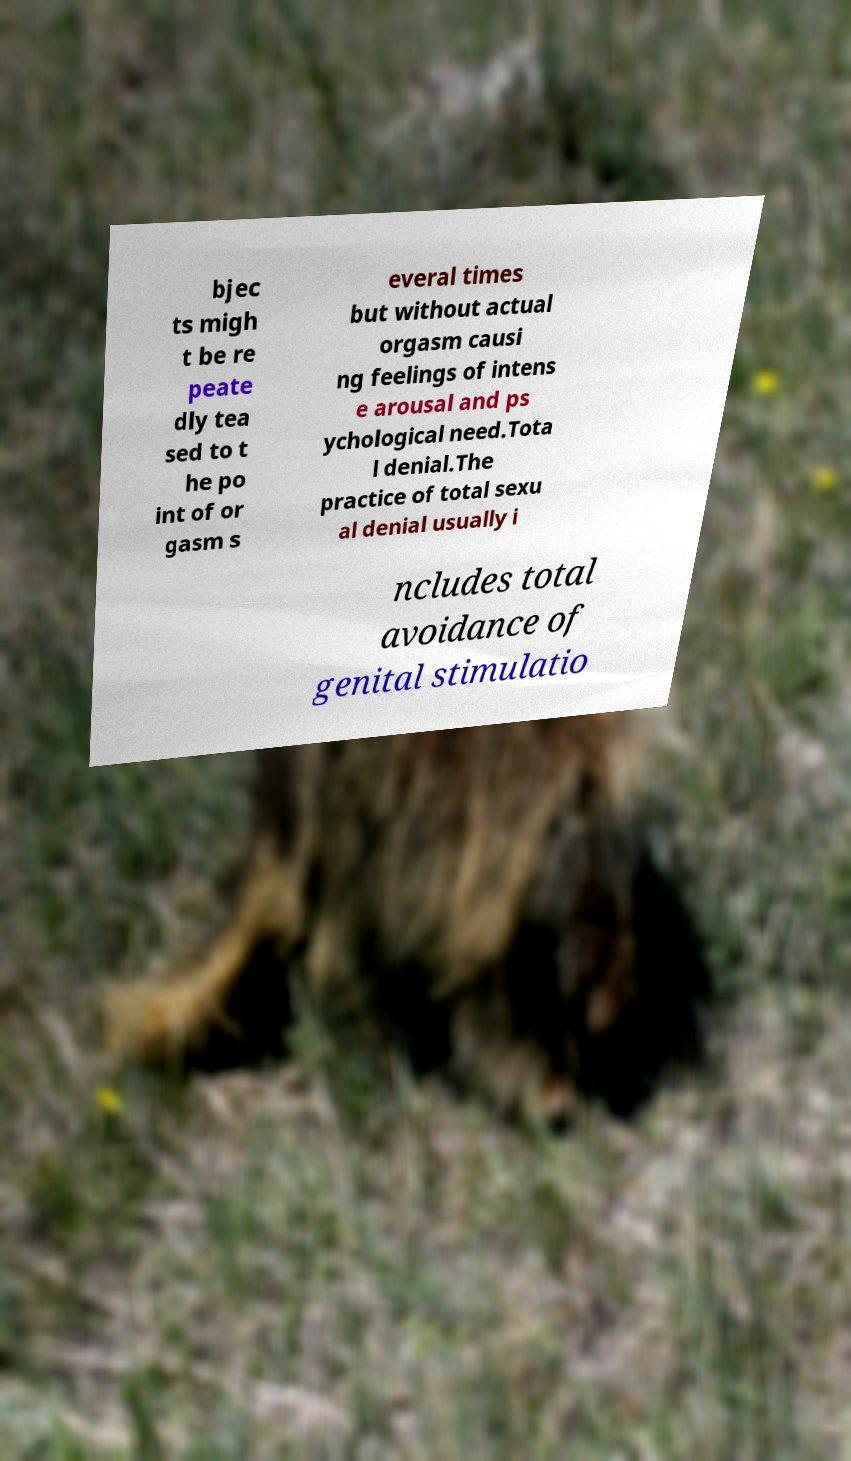Please identify and transcribe the text found in this image. bjec ts migh t be re peate dly tea sed to t he po int of or gasm s everal times but without actual orgasm causi ng feelings of intens e arousal and ps ychological need.Tota l denial.The practice of total sexu al denial usually i ncludes total avoidance of genital stimulatio 